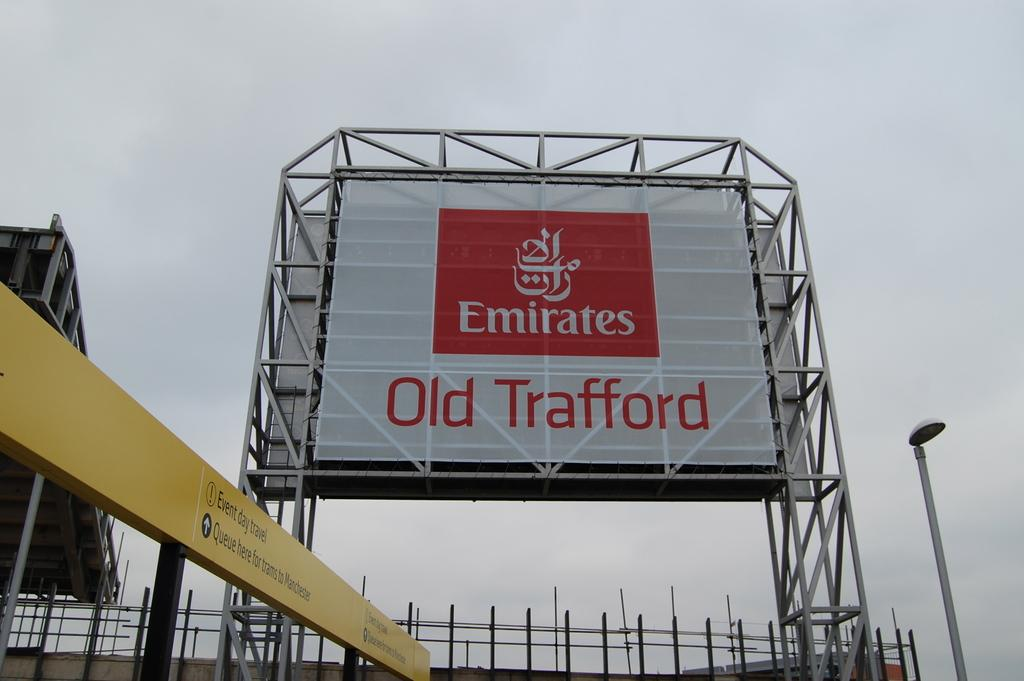<image>
Relay a brief, clear account of the picture shown. A large white sign says Emirates Old Trafford. 